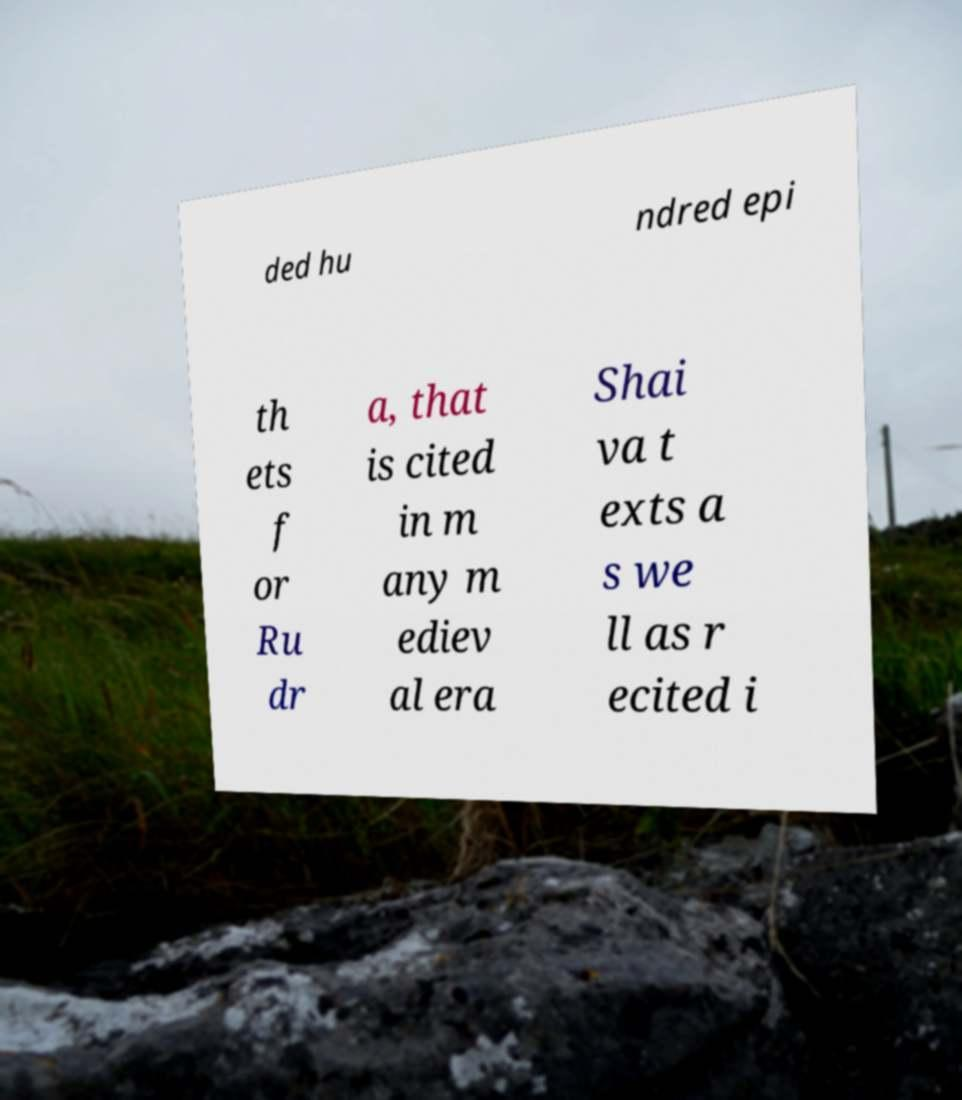What messages or text are displayed in this image? I need them in a readable, typed format. ded hu ndred epi th ets f or Ru dr a, that is cited in m any m ediev al era Shai va t exts a s we ll as r ecited i 